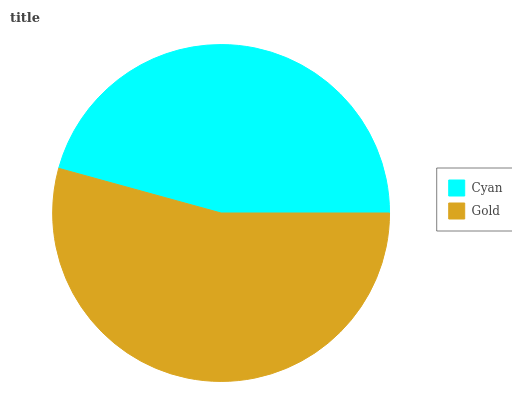Is Cyan the minimum?
Answer yes or no. Yes. Is Gold the maximum?
Answer yes or no. Yes. Is Gold the minimum?
Answer yes or no. No. Is Gold greater than Cyan?
Answer yes or no. Yes. Is Cyan less than Gold?
Answer yes or no. Yes. Is Cyan greater than Gold?
Answer yes or no. No. Is Gold less than Cyan?
Answer yes or no. No. Is Gold the high median?
Answer yes or no. Yes. Is Cyan the low median?
Answer yes or no. Yes. Is Cyan the high median?
Answer yes or no. No. Is Gold the low median?
Answer yes or no. No. 